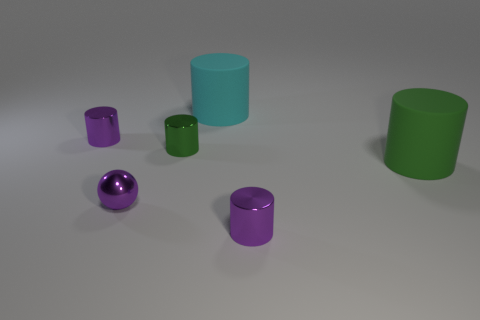There is another rubber thing that is the same size as the green matte object; what is its color?
Your response must be concise. Cyan. How many things are things to the left of the purple metal ball or big green blocks?
Offer a very short reply. 1. What number of other things are there of the same size as the green matte cylinder?
Provide a succinct answer. 1. What size is the cyan cylinder that is on the right side of the tiny green cylinder?
Your answer should be compact. Large. There is a green thing that is made of the same material as the purple sphere; what is its shape?
Offer a very short reply. Cylinder. What is the color of the big rubber thing that is in front of the purple cylinder that is behind the small purple ball?
Make the answer very short. Green. How many big things are green shiny things or purple metal spheres?
Give a very brief answer. 0. What is the material of the other green object that is the same shape as the green rubber object?
Provide a succinct answer. Metal. Is there anything else that is the same material as the tiny purple sphere?
Provide a succinct answer. Yes. What is the color of the small metal sphere?
Your response must be concise. Purple. 